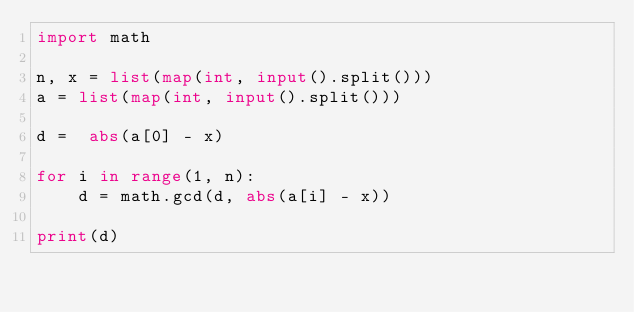<code> <loc_0><loc_0><loc_500><loc_500><_Python_>import math

n, x = list(map(int, input().split()))
a = list(map(int, input().split()))

d =  abs(a[0] - x)

for i in range(1, n):
    d = math.gcd(d, abs(a[i] - x))

print(d)</code> 